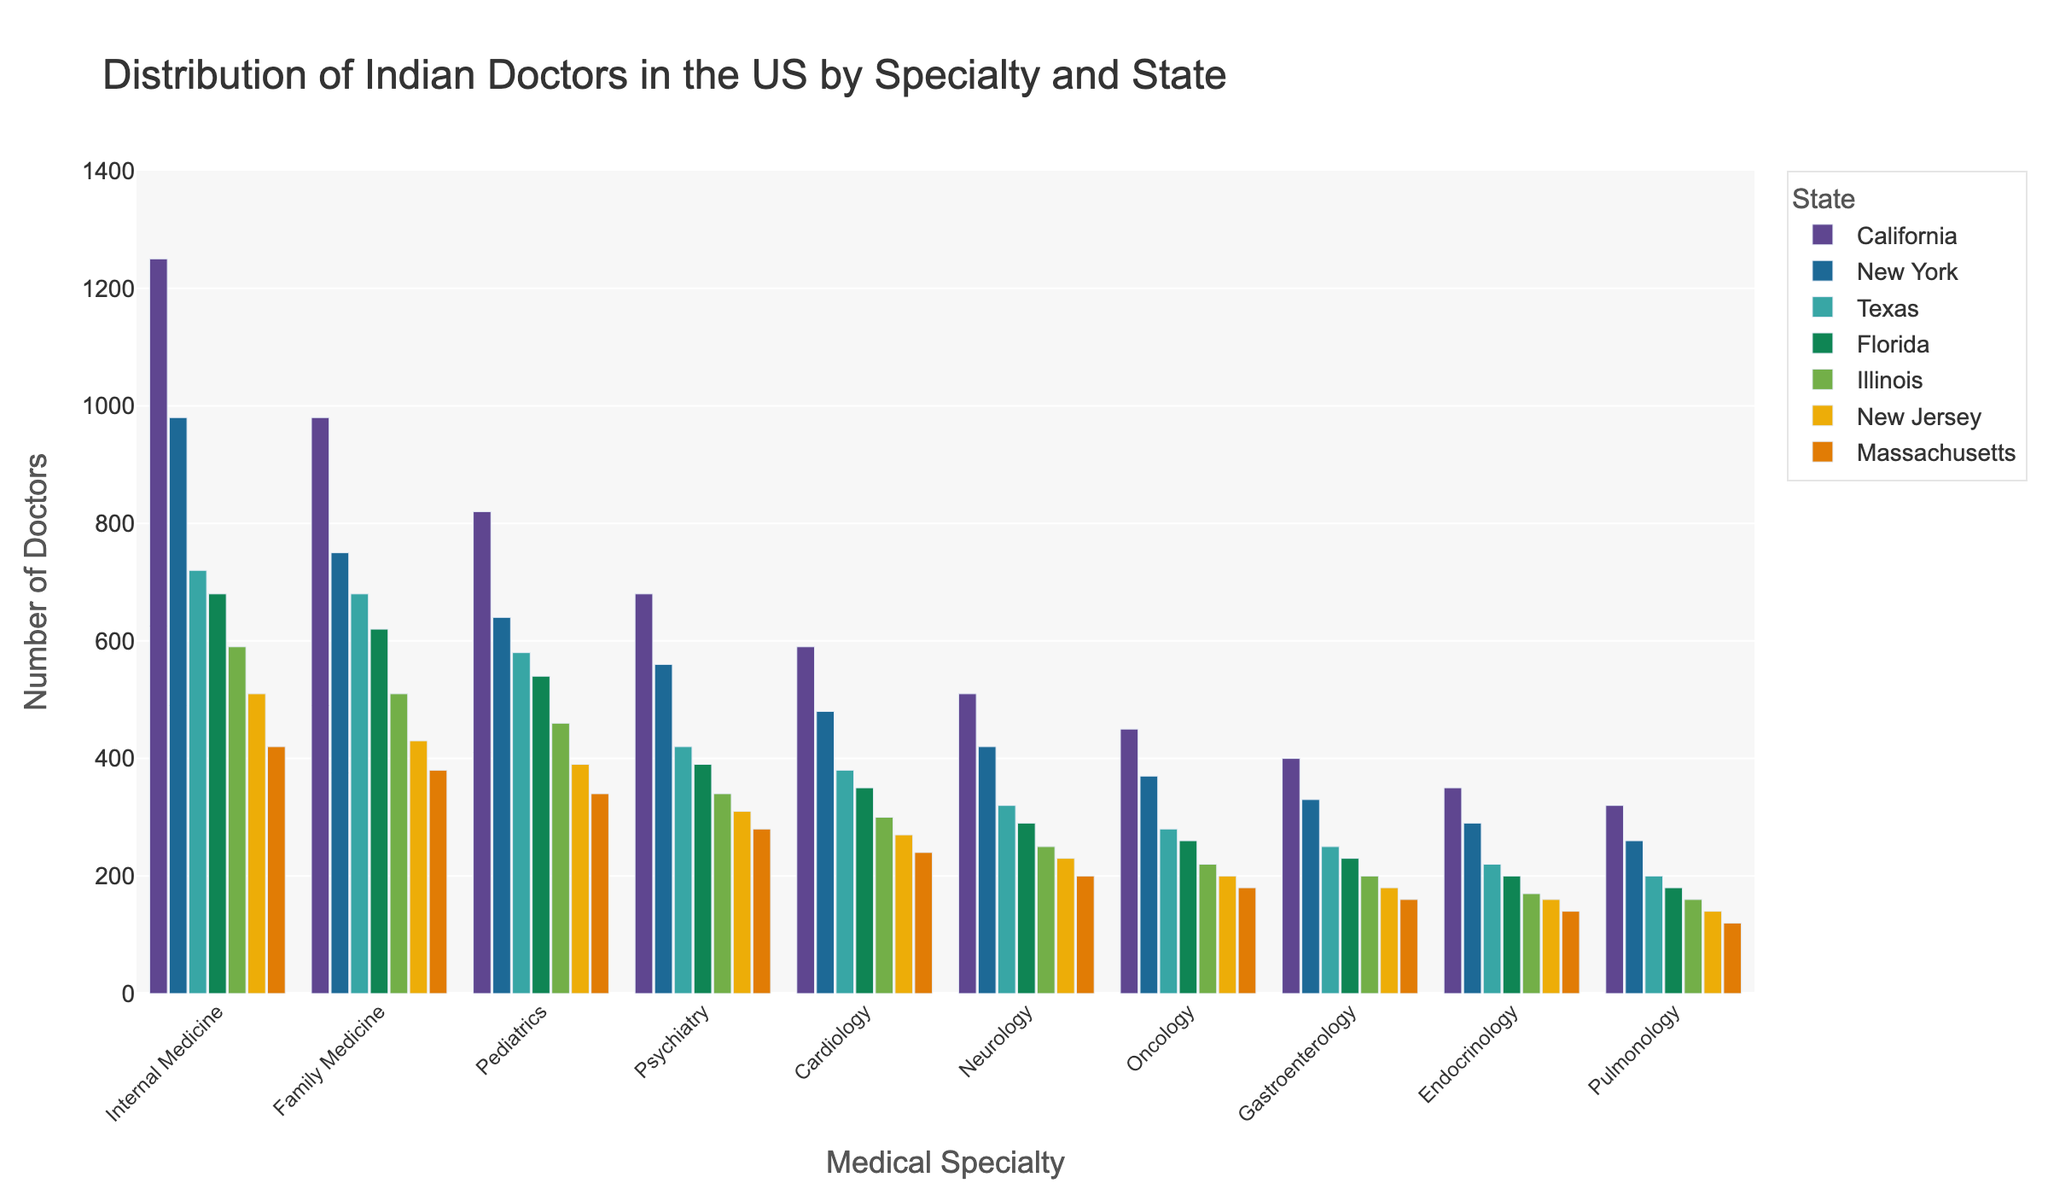What is the most common specialty among Indian doctors in California? Look at the bar heights for California and identify the tallest bar. The tallest bar represents Internal Medicine, indicating it has the highest number of doctors.
Answer: Internal Medicine Which state has the least number of Indian doctors in Oncology? Compare the lengths of the bars for Oncology across all states. The shortest bar appears for Massachusetts.
Answer: Massachusetts How many Indian doctors practice Family Medicine in New York and Texas combined? Find the number of doctors for Family Medicine in New York (750) and Texas (680), and then add these two values together: 750 + 680 = 1430.
Answer: 1430 Which specialty has the smallest difference in the number of Indian doctors between Florida and Illinois? Calculate the differences in doctor counts between Florida and Illinois for all specialties, and find the smallest difference:
Internal Medicine: 680 - 590 = 90
Family Medicine: 620 - 510 = 110
Pediatrics: 540 - 460 = 80
Psychiatry: 390 - 340 = 50
Cardiology: 350 - 300 = 50
Neurology: 290 - 250 = 40
Oncology: 260 - 220 = 40
Gastroenterology: 230 - 200 = 30
Endocrinology: 200 - 170 = 30
Pulmonology: 180 - 160 = 20
The smallest difference is for Pulmonology (20).
Answer: Pulmonology Which state has the highest total number of Indian doctors across all specialties? Sum the numbers for each state across all specialties and compare:
California: 1250 + 980 + 820 + 680 + 590 + 510 + 450 + 400 + 350 + 320 = 6350
New York: 980 + 750 + 640 + 560 + 480 + 420 + 370 + 330 + 290 + 260 = 5080
Texas: 720 + 680 + 580 + 420 + 380 + 320 + 280 + 250 + 220 + 200 = 4050
Florida: 680 + 620 + 540 + 390 + 350 + 290 + 260 + 230 + 200 + 180 = 3740
Illinois: 590 + 510 + 460 + 340 + 300 + 250 + 220 + 200 + 170 + 160 = 3200
New Jersey: 510 + 430 + 390 + 310 + 270 + 230 + 200 + 180 + 160 + 140 = 2820
Massachusetts: 420 + 380 + 340 + 280 + 240 + 200 + 180 + 160 + 140 + 120 = 2460
California has the highest total number (6350).
Answer: California What's the average number of Indian doctors in Pediatrics across all states? Sum the numbers for Pediatrics across all states and divide by the number of states:
(820 + 640 + 580 + 540 + 460 + 390 + 340) / 7 = 3770 / 7 ≈ 539
Answer: 539 Compare the number of Indian doctors in Internal Medicine between New York and New Jersey. Which state has more, and by how much? Subtract the number of Internal Medicine doctors in New Jersey (510) from New York (980): 980 - 510 = 470. New York has 470 more doctors in Internal Medicine than New Jersey.
Answer: New York, 470 Which specialty has the second highest number of Indian doctors in California? Observe the bars for California and identify the second tallest one. The tallest bar is Internal Medicine (1250), and the second tallest is Family Medicine (980).
Answer: Family Medicine Which two specialties have the highest number of doctors in Massachusetts, and how many doctors are there in each? Observe the bars for Massachusetts and identify the two tallest ones. The first is Internal Medicine (420), and the second is Family Medicine (380).
Answer: Internal Medicine: 420, Family Medicine: 380 What is the total number of Indian doctors in Cardiology in New York, New Jersey, and Illinois combined? Sum the numbers for Cardiology in these three states: New York (480), New Jersey (270), and Illinois (300): 480 + 270 + 300 = 1050.
Answer: 1050 